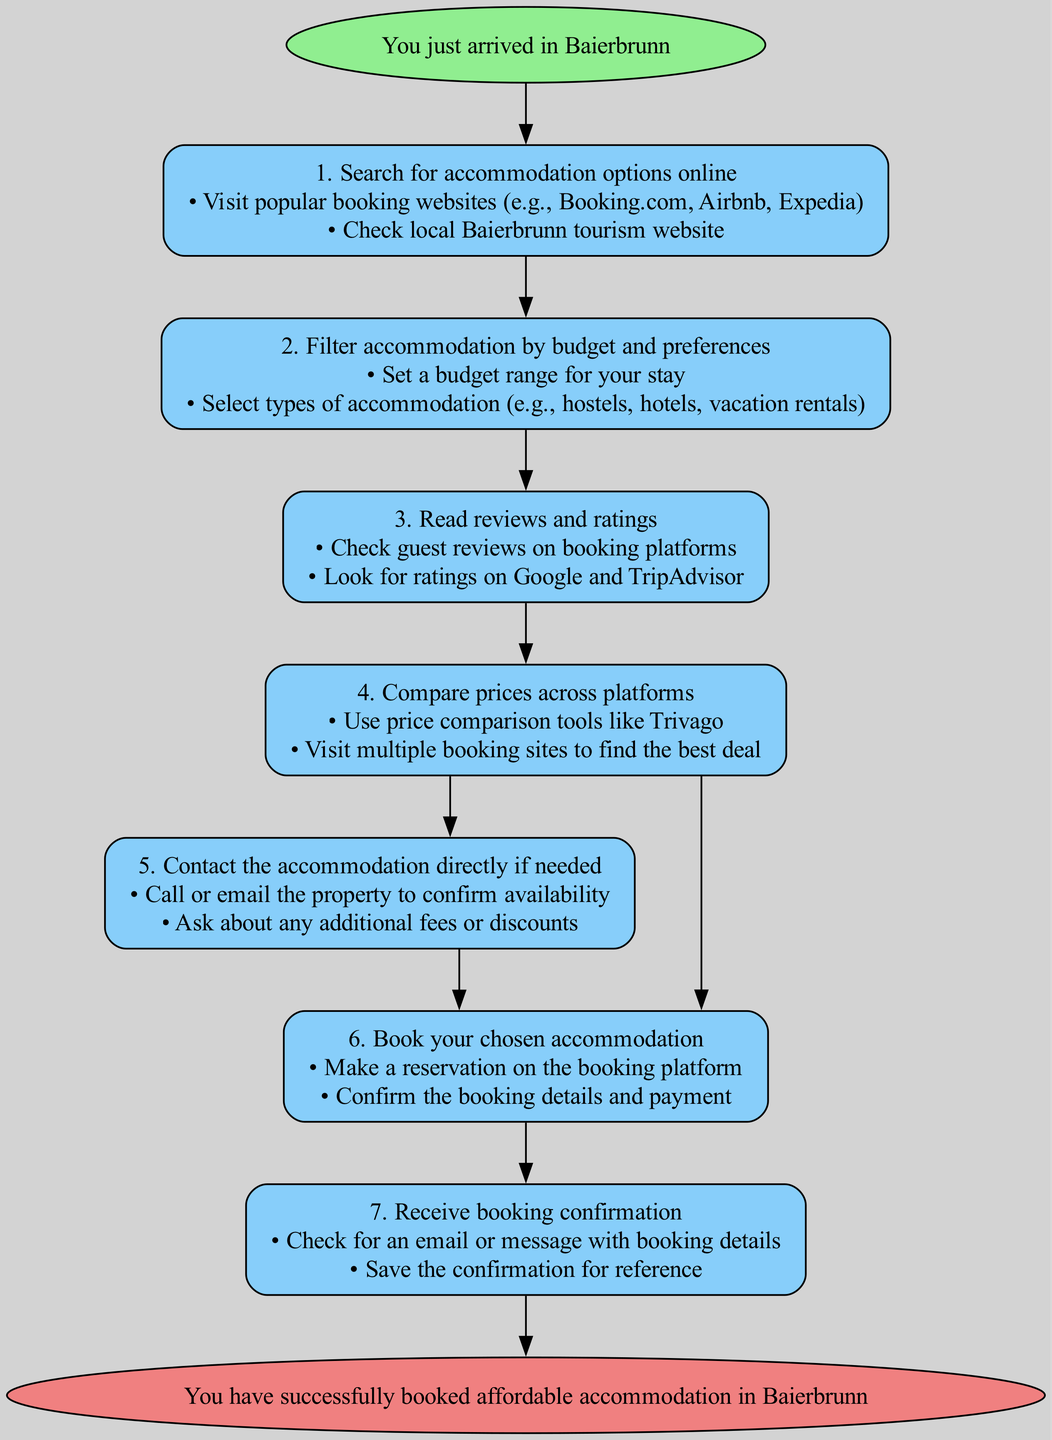What is the first step in the flow chart? The first step in the flow chart is indicated directly after the Start node. It states "Search for accommodation options online."
Answer: Search for accommodation options online How many steps are in the flow chart? By counting the nodes labeled as steps in the diagram, we find there are a total of seven steps, from the first step to the sixth step before the End node.
Answer: 7 What actions are included in Step 2? Step 2 details the actions required to filter accommodation by budget and preferences. It specifies setting a budget range and selecting types of accommodation.
Answer: Set a budget range for your stay; Select types of accommodation Which step involves comparing prices across platforms? To find the step that mentions comparing prices, we look through the flow from Step 1 and note that Step 4 distinctly mentions comparing prices across platforms.
Answer: Compare prices across platforms What does Step 7 require the user to do? In Step 7, the action required is to receive booking confirmation by checking for an email or message with booking details.
Answer: Check for an email or message with booking details If someone completes Step 5, what is the next step they should proceed to? After completing Step 5, which involves contacting the accommodation directly, the next step to proceed to is Step 6, which is about booking chosen accommodation.
Answer: Book your chosen accommodation Which step requires reading reviews and ratings? Step 3 requires the user to read reviews and ratings as part of the process before making a booking decision.
Answer: Read reviews and ratings How does one start the process according to the flow chart? The flow chart begins with the Start node, which indicates that the process is initiated as soon as someone arrives in Baierbrunn.
Answer: You just arrived in Baierbrunn 